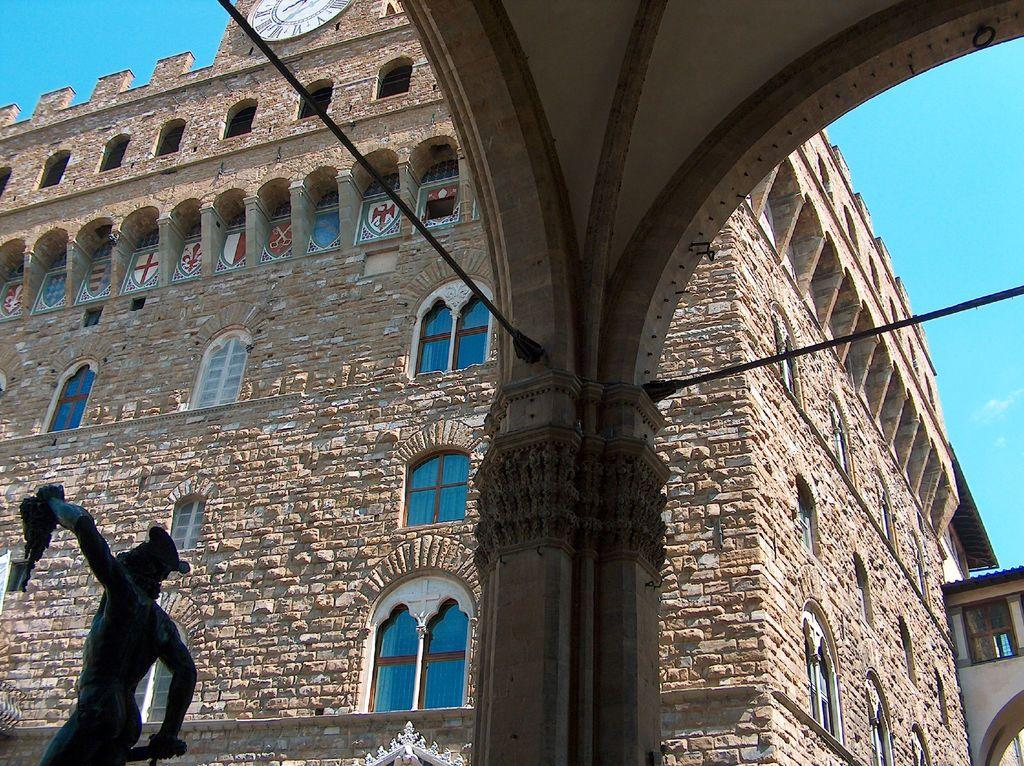What type of building is shown in the image? The building in the image has glass windows. What can be seen on the left side of the image? There is a statue on the left side bottom of the image. What is visible at the top of the image? The sky is visible at the top of the image. What architectural feature is in the middle of the image? There is a pillar in the middle of the image. What type of wound does the lawyer have in the image? There is no lawyer or wound present in the image. 